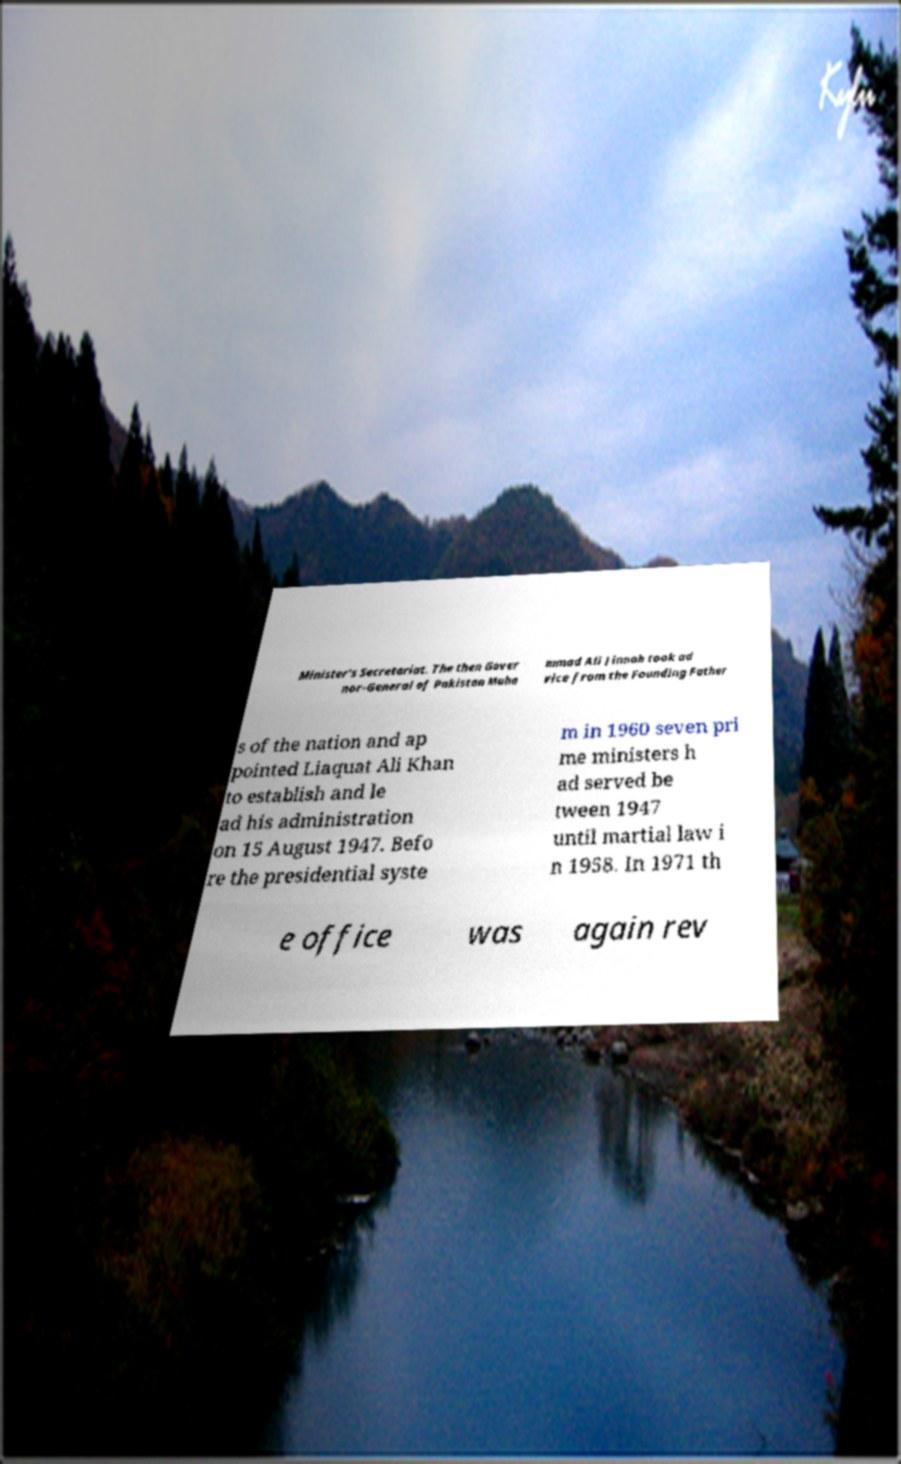Could you extract and type out the text from this image? Minister's Secretariat. The then Gover nor-General of Pakistan Muha mmad Ali Jinnah took ad vice from the Founding Father s of the nation and ap pointed Liaquat Ali Khan to establish and le ad his administration on 15 August 1947. Befo re the presidential syste m in 1960 seven pri me ministers h ad served be tween 1947 until martial law i n 1958. In 1971 th e office was again rev 